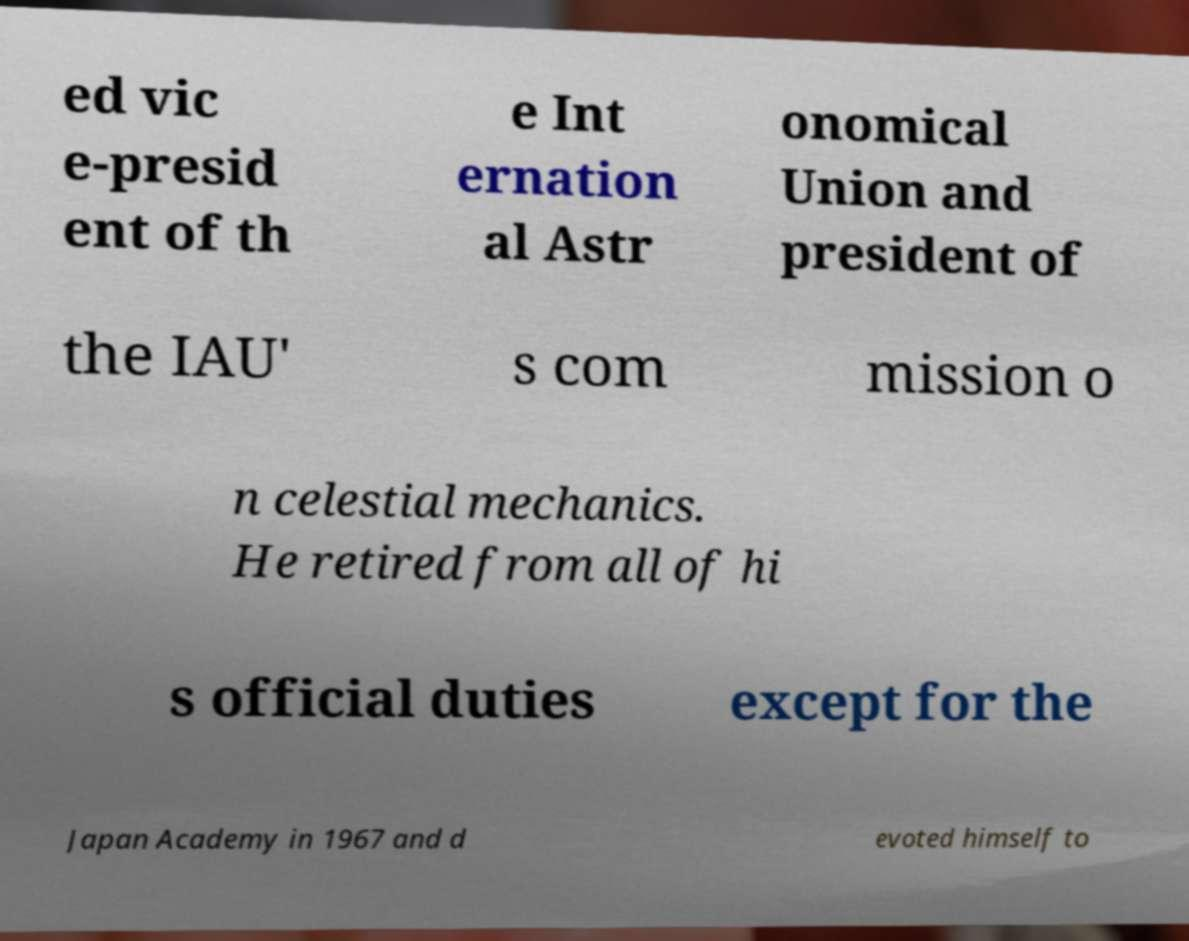Please identify and transcribe the text found in this image. ed vic e-presid ent of th e Int ernation al Astr onomical Union and president of the IAU' s com mission o n celestial mechanics. He retired from all of hi s official duties except for the Japan Academy in 1967 and d evoted himself to 